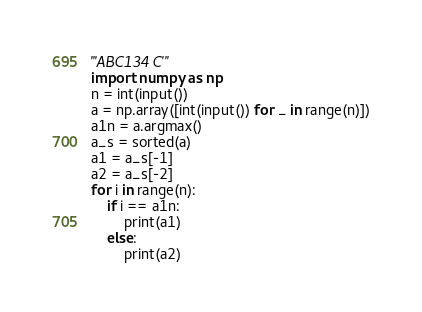<code> <loc_0><loc_0><loc_500><loc_500><_Python_>'''ABC134 C'''
import numpy as np
n = int(input())
a = np.array([int(input()) for _ in range(n)])
a1n = a.argmax()
a_s = sorted(a)
a1 = a_s[-1]
a2 = a_s[-2]
for i in range(n):
    if i == a1n:
        print(a1)
    else:
        print(a2)</code> 